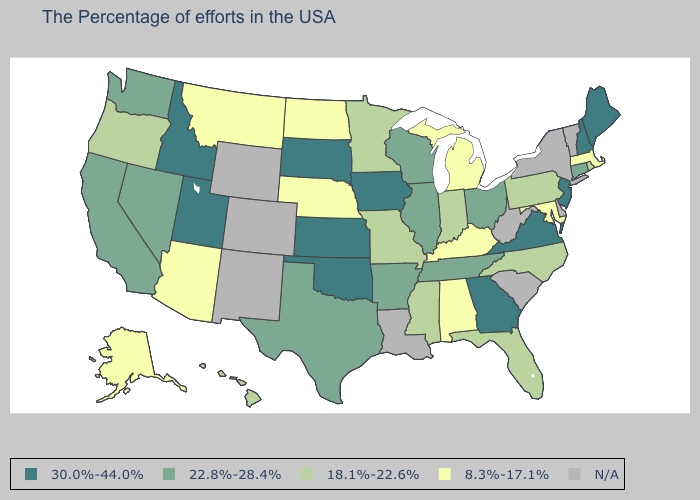How many symbols are there in the legend?
Quick response, please. 5. What is the lowest value in the Northeast?
Keep it brief. 8.3%-17.1%. How many symbols are there in the legend?
Give a very brief answer. 5. What is the value of Montana?
Keep it brief. 8.3%-17.1%. Is the legend a continuous bar?
Concise answer only. No. Does Minnesota have the highest value in the USA?
Answer briefly. No. What is the value of Kentucky?
Keep it brief. 8.3%-17.1%. Does Ohio have the lowest value in the USA?
Concise answer only. No. What is the lowest value in states that border Ohio?
Write a very short answer. 8.3%-17.1%. Which states hav the highest value in the Northeast?
Give a very brief answer. Maine, New Hampshire, New Jersey. Name the states that have a value in the range 18.1%-22.6%?
Short answer required. Rhode Island, Pennsylvania, North Carolina, Florida, Indiana, Mississippi, Missouri, Minnesota, Oregon, Hawaii. Name the states that have a value in the range 30.0%-44.0%?
Answer briefly. Maine, New Hampshire, New Jersey, Virginia, Georgia, Iowa, Kansas, Oklahoma, South Dakota, Utah, Idaho. What is the value of Massachusetts?
Give a very brief answer. 8.3%-17.1%. What is the value of Indiana?
Be succinct. 18.1%-22.6%. 